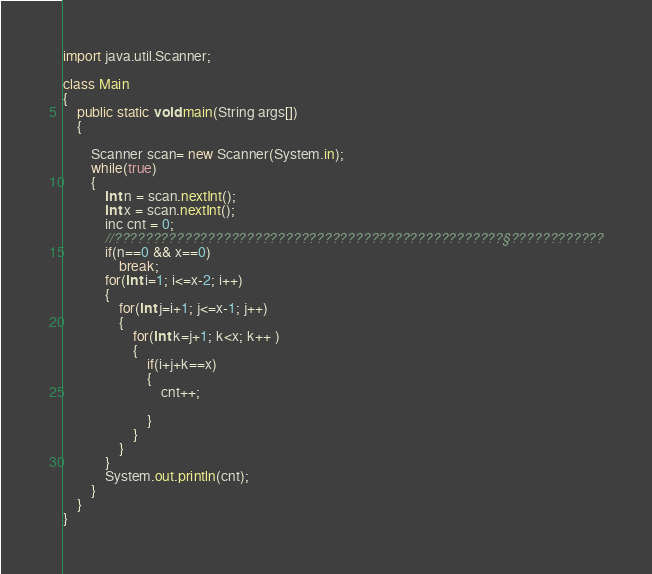<code> <loc_0><loc_0><loc_500><loc_500><_Java_>import java.util.Scanner;

class Main
{
	public static void main(String args[])
	{
		
		Scanner scan= new Scanner(System.in);
		while(true)
		{
			int n = scan.nextInt();
			int x = scan.nextInt();
			inc cnt = 0;
			//??????????????????????????????????????????????????§????????????
			if(n==0 && x==0)
				break;
			for(int i=1; i<=x-2; i++)
			{
				for(int j=i+1; j<=x-1; j++)
				{
					for(int k=j+1; k<x; k++ )
					{
						if(i+j+k==x)
						{
							cnt++;
						
						}
					}
				}
			}
			System.out.println(cnt);
		}
	}
}</code> 